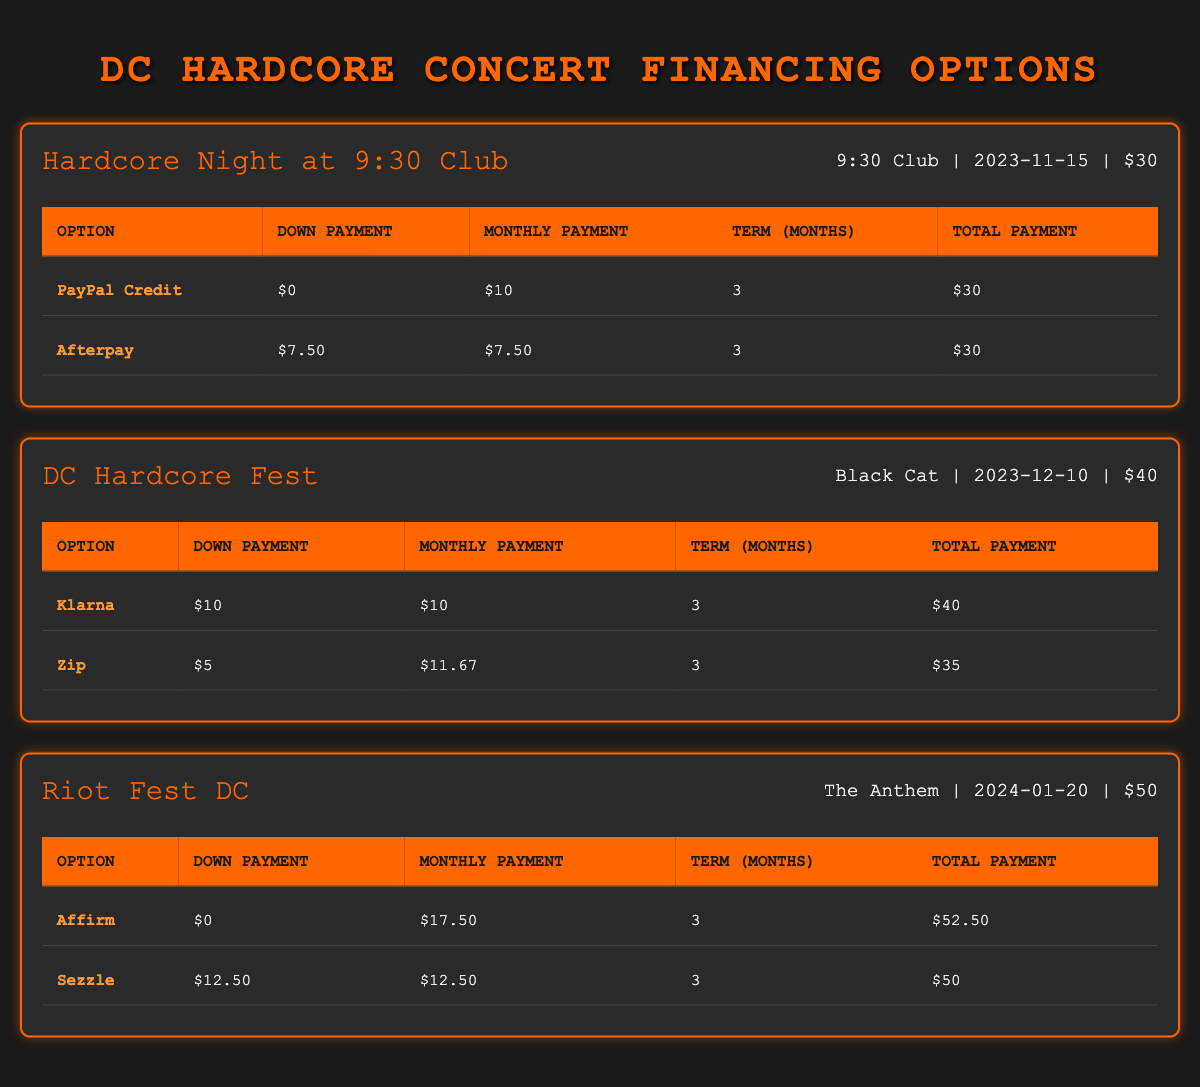What are the total payment amounts required for the financing options of the Hardcore Night at 9:30 Club? The financing options listed for the Hardcore Night at 9:30 Club are PayPal Credit (total payment $30) and Afterpay (total payment $30). Summing these values gives 30 + 30 = 60.
Answer: 60 How much do you need to pay upfront for the DC Hardcore Fest if you choose the "Zip" option? The "Zip" option requires a down payment of $5, which is stated directly in the table under the "Down Payment" column for that option.
Answer: 5 Which financing option for Riot Fest DC has the highest total payment? The financing options for Riot Fest DC are Affirm (total payment $52.50) and Sezzle (total payment $50). Since $52.50 is greater than $50, Affirm is the option with the highest total payment.
Answer: Affirm Is it true that all concerts listed have at least one financing option that requires a zero down payment? The Hardcore Night at 9:30 Club has PayPal Credit with a zero down payment, Riot Fest DC has Affirm with a zero down payment, and no other options for DC Hardcore Fest and Riot Fest DC require zero down payment. Therefore, it is true that all concerts have at least one zero down payment financing option.
Answer: Yes What is the average monthly payment for all financing options across all concerts? The monthly payments are 10 (PayPal Credit), 7.50 (Afterpay) for the Hardcore Night, 10 (Klarna), 11.67 (Zip) for the DC Hardcore Fest, and 17.50 (Affirm), 12.50 (Sezzle) for the Riot Fest DC. Summing these gives 10 + 7.50 + 10 + 11.67 + 17.50 + 12.50 = 69.17. Dividing 69.17 by 6 gives an average of approximately 11.53.
Answer: 11.53 